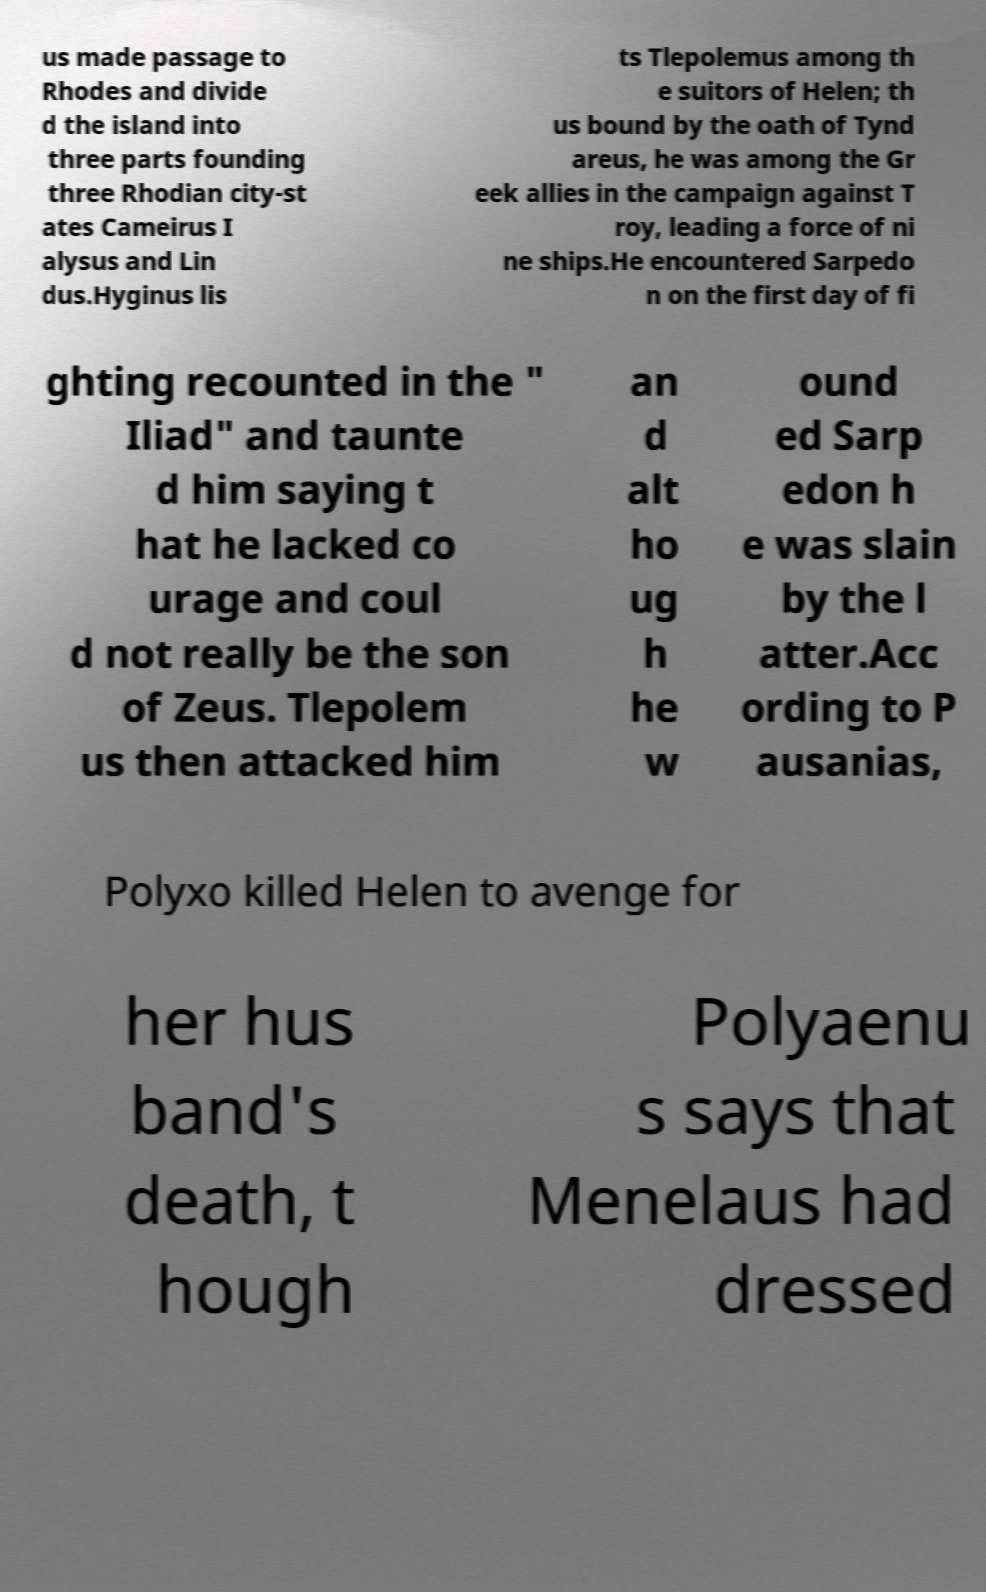Please read and relay the text visible in this image. What does it say? us made passage to Rhodes and divide d the island into three parts founding three Rhodian city-st ates Cameirus I alysus and Lin dus.Hyginus lis ts Tlepolemus among th e suitors of Helen; th us bound by the oath of Tynd areus, he was among the Gr eek allies in the campaign against T roy, leading a force of ni ne ships.He encountered Sarpedo n on the first day of fi ghting recounted in the " Iliad" and taunte d him saying t hat he lacked co urage and coul d not really be the son of Zeus. Tlepolem us then attacked him an d alt ho ug h he w ound ed Sarp edon h e was slain by the l atter.Acc ording to P ausanias, Polyxo killed Helen to avenge for her hus band's death, t hough Polyaenu s says that Menelaus had dressed 